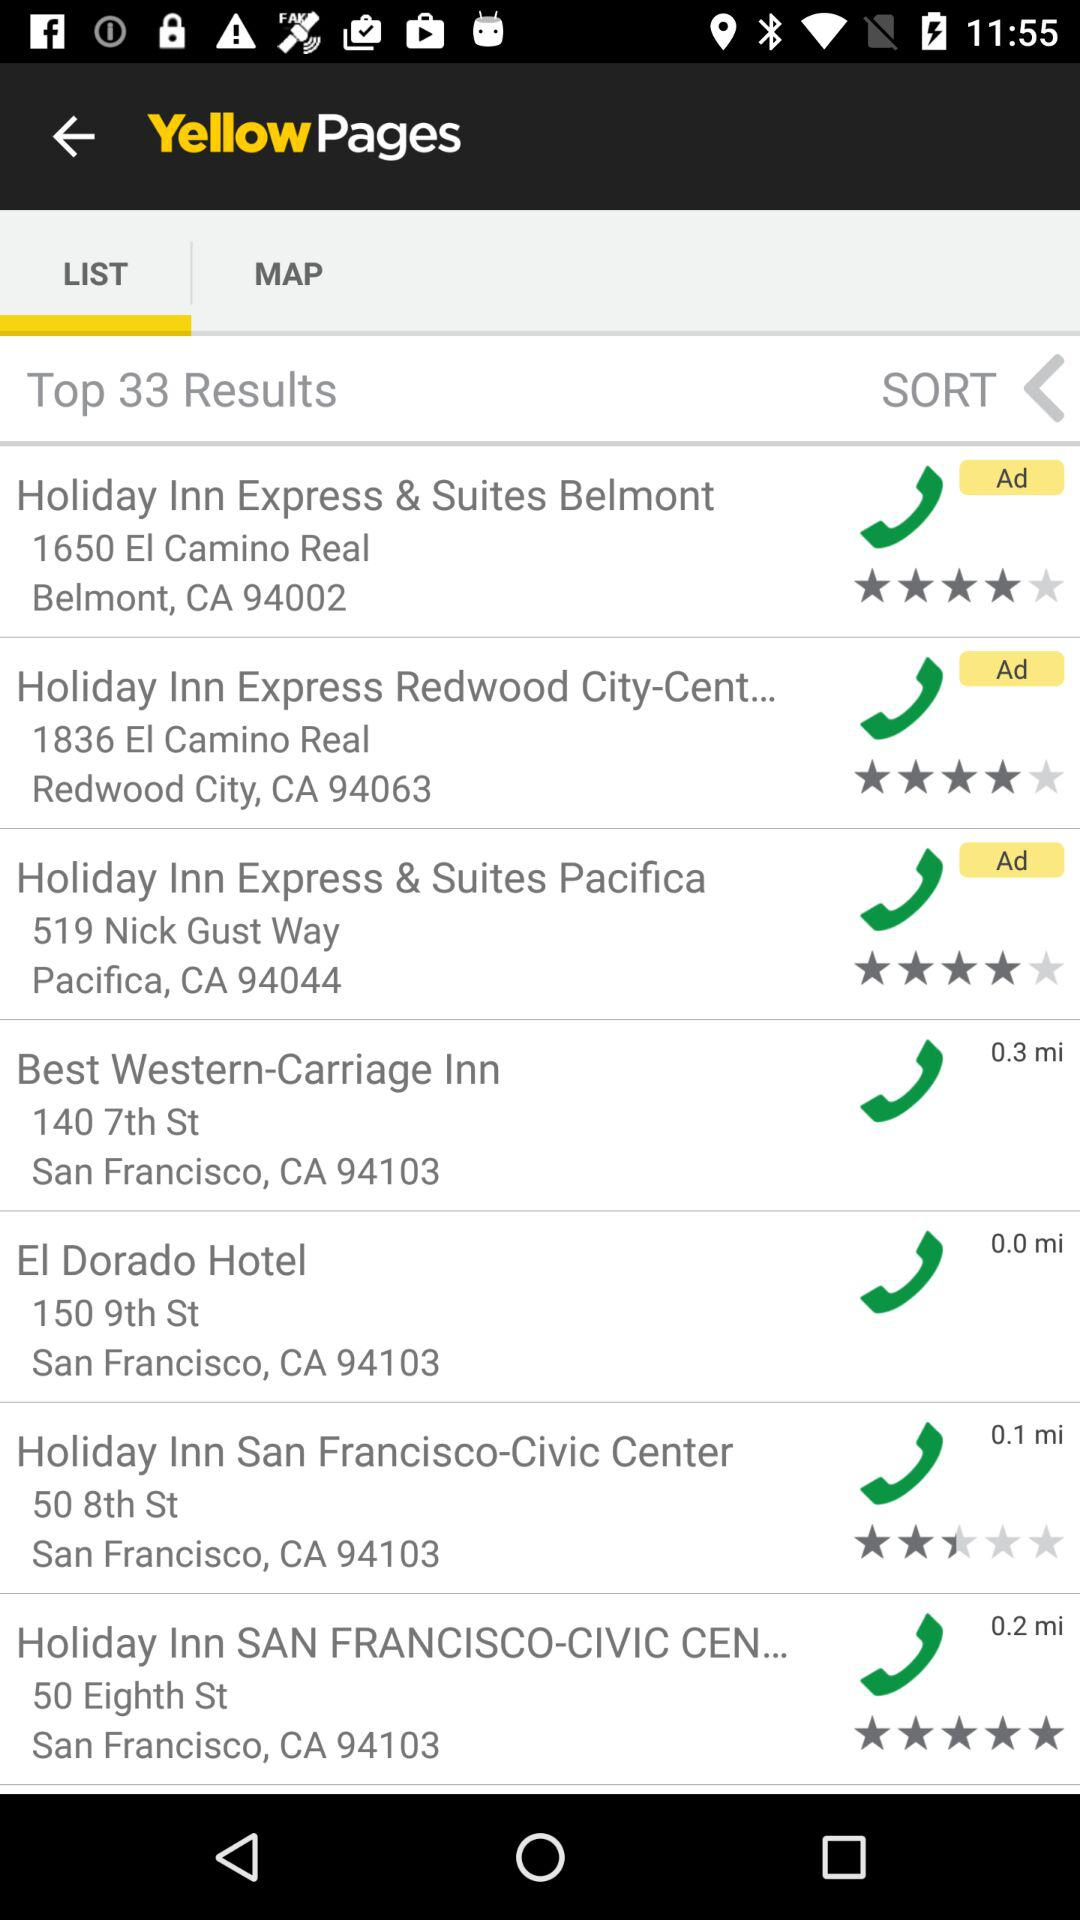Which tab is selected? The selected tab is "LIST". 